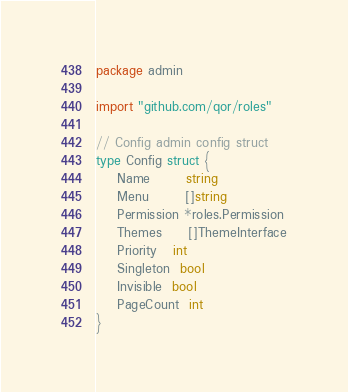<code> <loc_0><loc_0><loc_500><loc_500><_Go_>package admin

import "github.com/qor/roles"

// Config admin config struct
type Config struct {
	Name       string
	Menu       []string
	Permission *roles.Permission
	Themes     []ThemeInterface
	Priority   int
	Singleton  bool
	Invisible  bool
	PageCount  int
}
</code> 